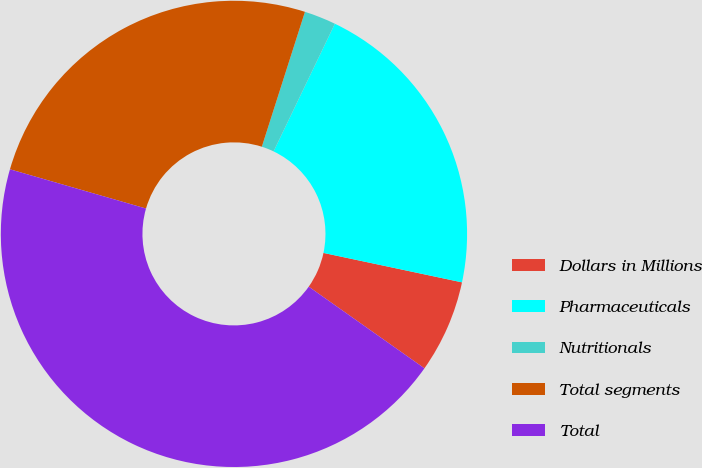Convert chart to OTSL. <chart><loc_0><loc_0><loc_500><loc_500><pie_chart><fcel>Dollars in Millions<fcel>Pharmaceuticals<fcel>Nutritionals<fcel>Total segments<fcel>Total<nl><fcel>6.45%<fcel>21.21%<fcel>2.2%<fcel>25.46%<fcel>44.69%<nl></chart> 